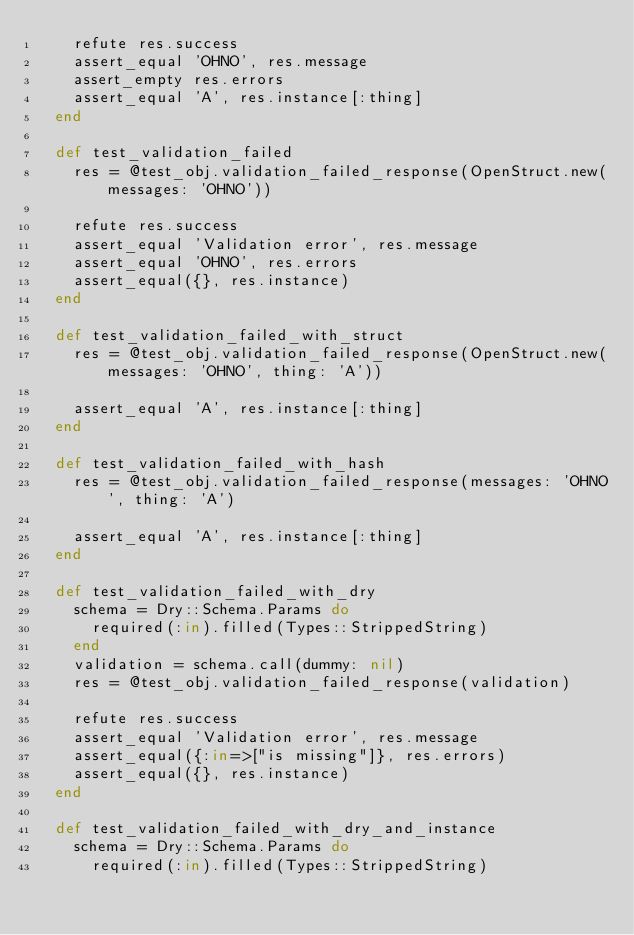<code> <loc_0><loc_0><loc_500><loc_500><_Ruby_>    refute res.success
    assert_equal 'OHNO', res.message
    assert_empty res.errors
    assert_equal 'A', res.instance[:thing]
  end

  def test_validation_failed
    res = @test_obj.validation_failed_response(OpenStruct.new(messages: 'OHNO'))

    refute res.success
    assert_equal 'Validation error', res.message
    assert_equal 'OHNO', res.errors
    assert_equal({}, res.instance)
  end

  def test_validation_failed_with_struct
    res = @test_obj.validation_failed_response(OpenStruct.new(messages: 'OHNO', thing: 'A'))

    assert_equal 'A', res.instance[:thing]
  end

  def test_validation_failed_with_hash
    res = @test_obj.validation_failed_response(messages: 'OHNO', thing: 'A')

    assert_equal 'A', res.instance[:thing]
  end

  def test_validation_failed_with_dry
    schema = Dry::Schema.Params do
      required(:in).filled(Types::StrippedString)
    end
    validation = schema.call(dummy: nil)
    res = @test_obj.validation_failed_response(validation)

    refute res.success
    assert_equal 'Validation error', res.message
    assert_equal({:in=>["is missing"]}, res.errors)
    assert_equal({}, res.instance)
  end

  def test_validation_failed_with_dry_and_instance
    schema = Dry::Schema.Params do
      required(:in).filled(Types::StrippedString)</code> 